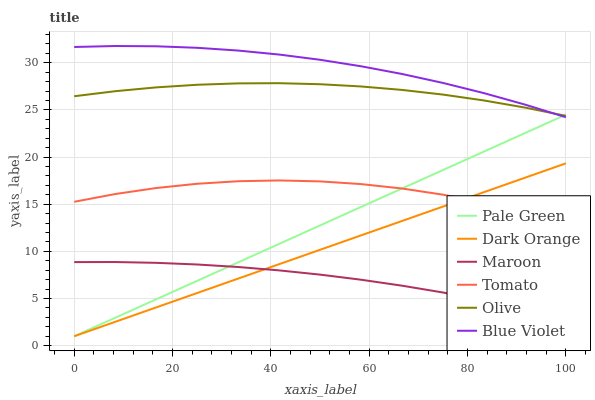Does Maroon have the minimum area under the curve?
Answer yes or no. Yes. Does Blue Violet have the maximum area under the curve?
Answer yes or no. Yes. Does Dark Orange have the minimum area under the curve?
Answer yes or no. No. Does Dark Orange have the maximum area under the curve?
Answer yes or no. No. Is Dark Orange the smoothest?
Answer yes or no. Yes. Is Tomato the roughest?
Answer yes or no. Yes. Is Maroon the smoothest?
Answer yes or no. No. Is Maroon the roughest?
Answer yes or no. No. Does Dark Orange have the lowest value?
Answer yes or no. Yes. Does Maroon have the lowest value?
Answer yes or no. No. Does Blue Violet have the highest value?
Answer yes or no. Yes. Does Dark Orange have the highest value?
Answer yes or no. No. Is Maroon less than Tomato?
Answer yes or no. Yes. Is Olive greater than Tomato?
Answer yes or no. Yes. Does Olive intersect Blue Violet?
Answer yes or no. Yes. Is Olive less than Blue Violet?
Answer yes or no. No. Is Olive greater than Blue Violet?
Answer yes or no. No. Does Maroon intersect Tomato?
Answer yes or no. No. 